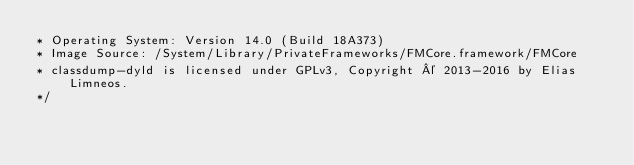<code> <loc_0><loc_0><loc_500><loc_500><_C_>* Operating System: Version 14.0 (Build 18A373)
* Image Source: /System/Library/PrivateFrameworks/FMCore.framework/FMCore
* classdump-dyld is licensed under GPLv3, Copyright © 2013-2016 by Elias Limneos.
*/

</code> 